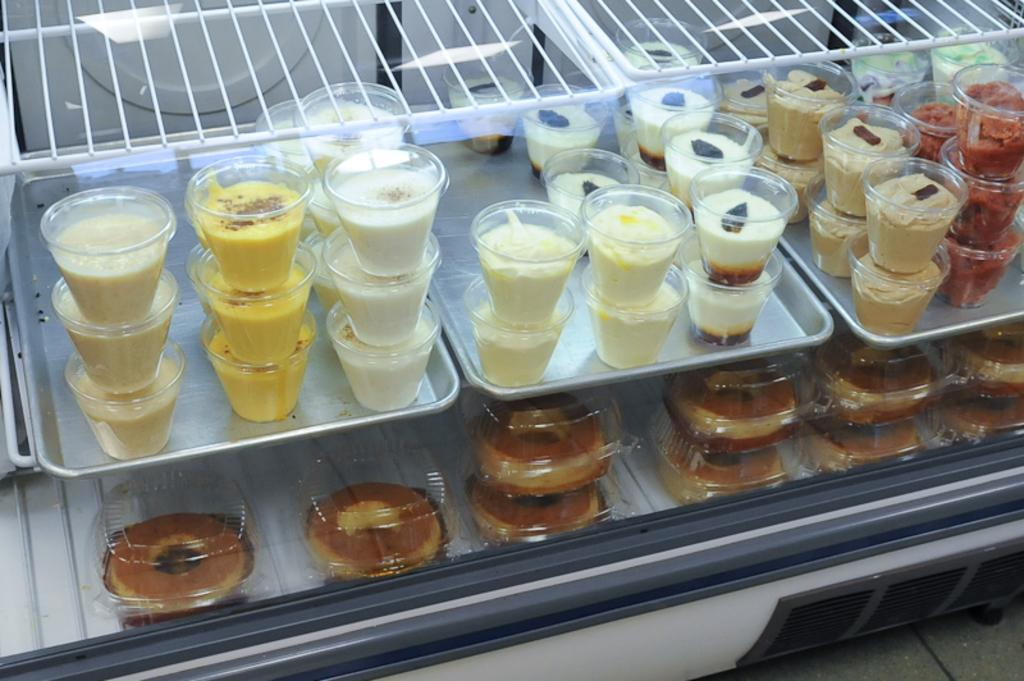What objects are visible in the image that are typically used for holding liquids? There are cups in the image. What else can be seen in the image besides the cups? There are food items in the image. Where are the cups and food items located? The cups and food items are in a refrigerator. What type of car can be seen parked next to the refrigerator in the image? There is no car present in the image; it only features cups and food items in a refrigerator. 